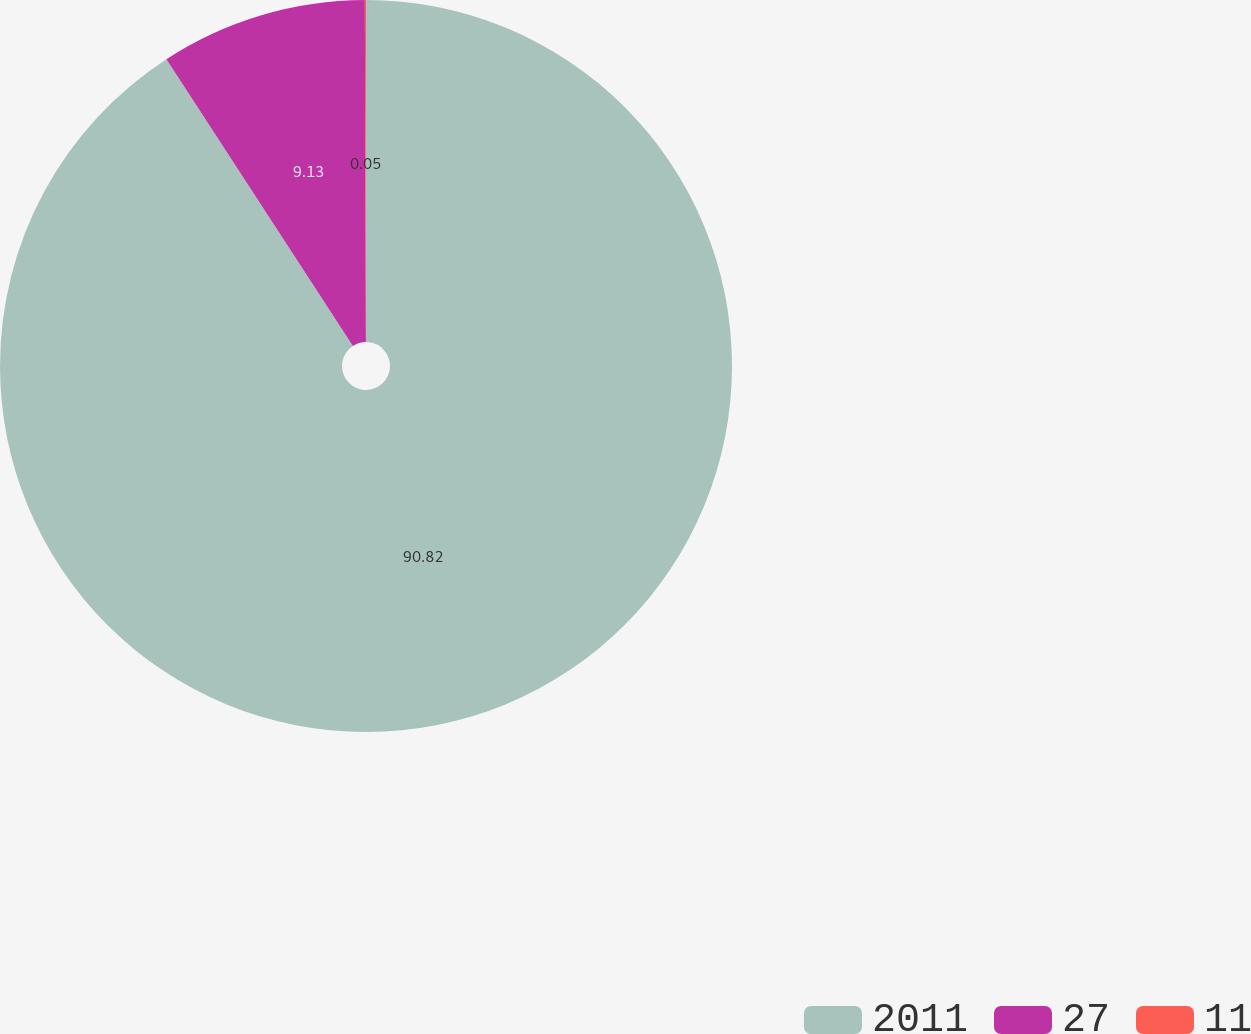Convert chart. <chart><loc_0><loc_0><loc_500><loc_500><pie_chart><fcel>2011<fcel>27<fcel>11<nl><fcel>90.82%<fcel>9.13%<fcel>0.05%<nl></chart> 